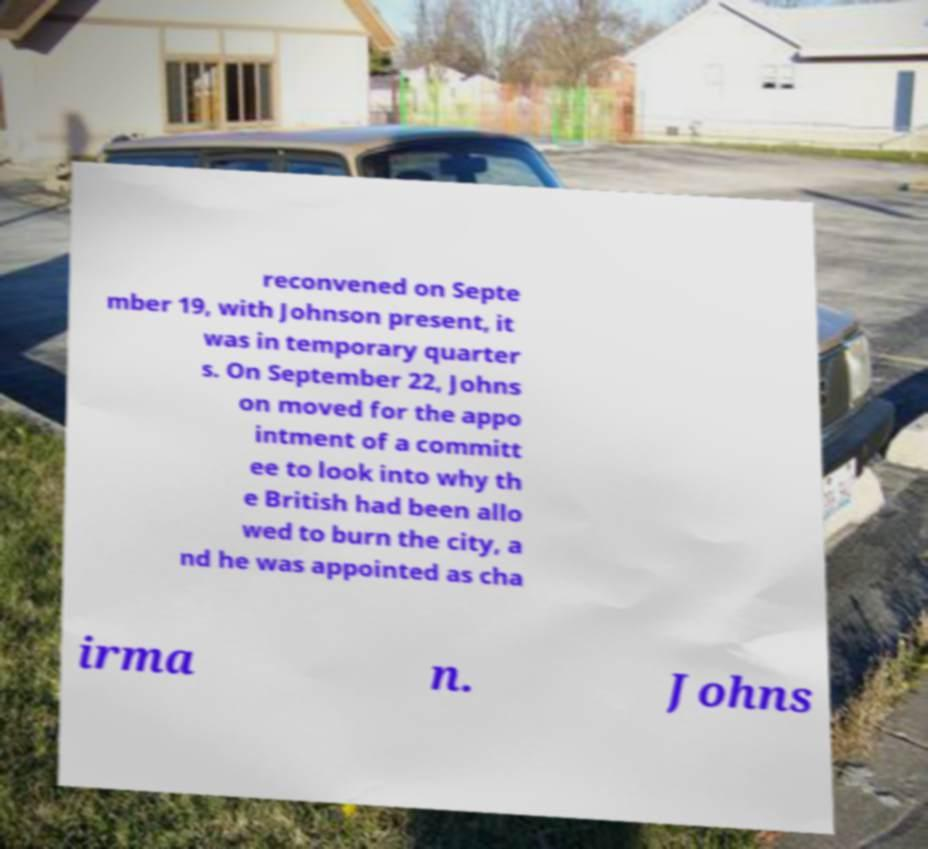Please identify and transcribe the text found in this image. reconvened on Septe mber 19, with Johnson present, it was in temporary quarter s. On September 22, Johns on moved for the appo intment of a committ ee to look into why th e British had been allo wed to burn the city, a nd he was appointed as cha irma n. Johns 